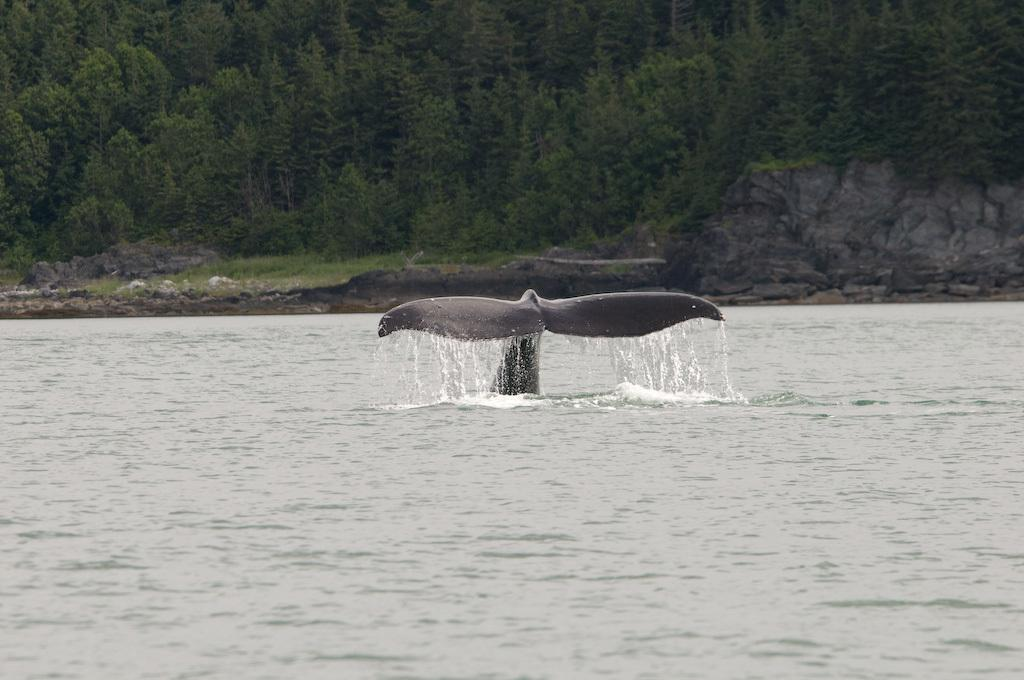What is present in the image that is not solid? There is water visible in the image. What type of animal can be seen in the image? There is a water animal in the image. What can be seen in the distance in the image? There are trees in the background of the image. What tax rate is applied to the water in the image? There is no tax rate applied to the water in the image, as it is a natural element and not subject to taxation. 